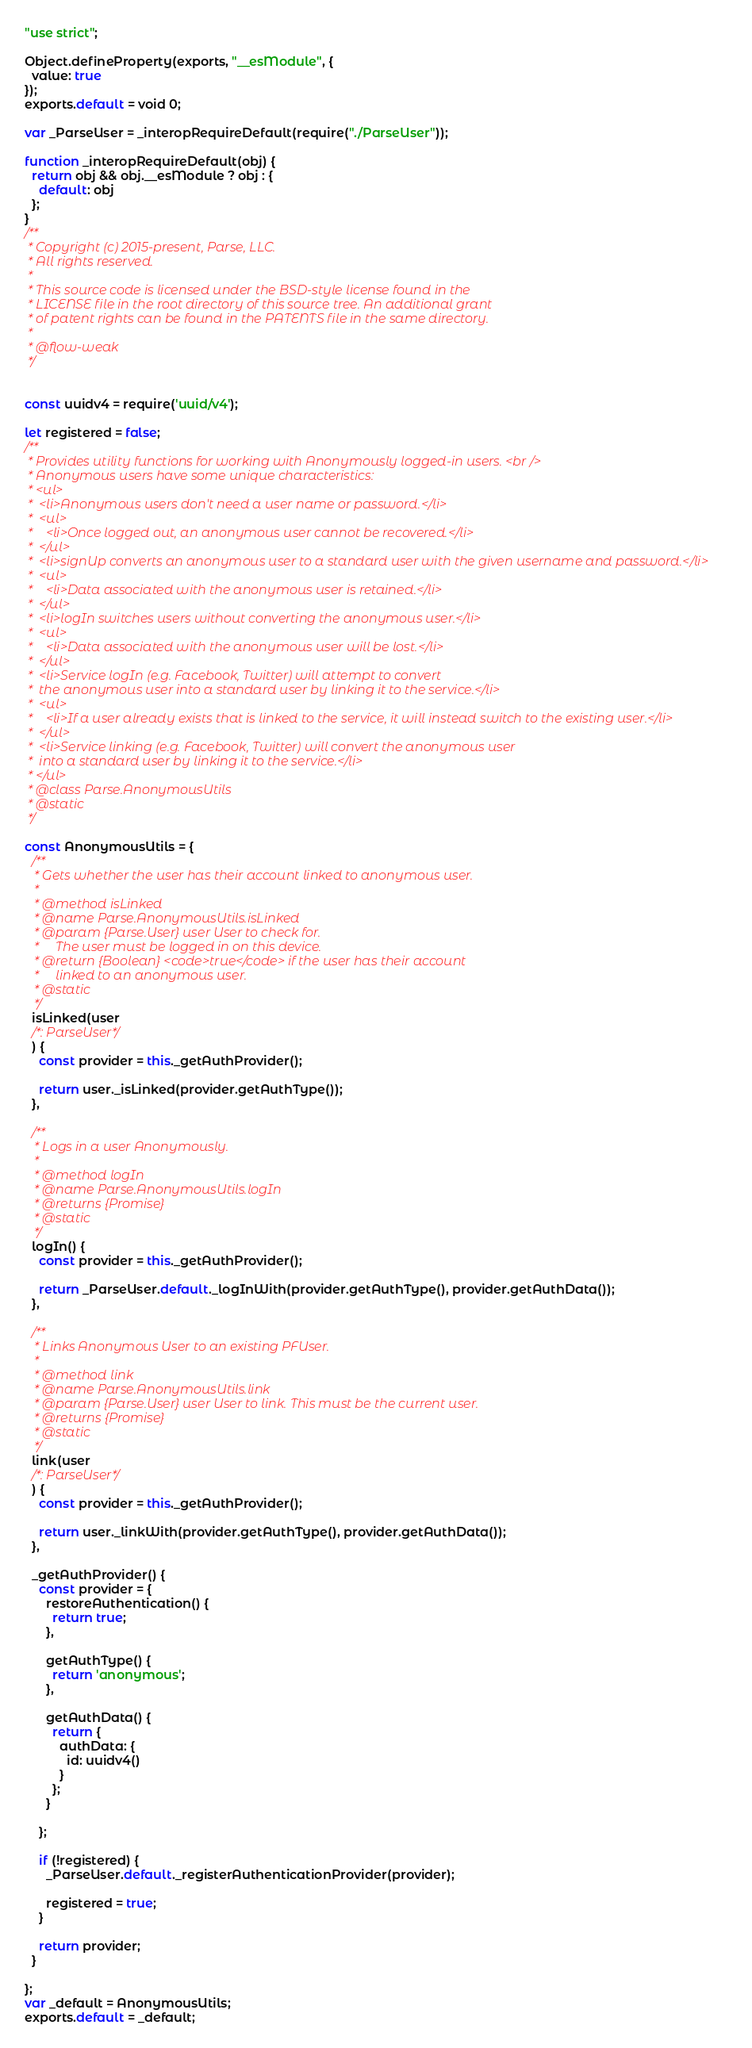Convert code to text. <code><loc_0><loc_0><loc_500><loc_500><_JavaScript_>"use strict";

Object.defineProperty(exports, "__esModule", {
  value: true
});
exports.default = void 0;

var _ParseUser = _interopRequireDefault(require("./ParseUser"));

function _interopRequireDefault(obj) {
  return obj && obj.__esModule ? obj : {
    default: obj
  };
}
/**
 * Copyright (c) 2015-present, Parse, LLC.
 * All rights reserved.
 *
 * This source code is licensed under the BSD-style license found in the
 * LICENSE file in the root directory of this source tree. An additional grant
 * of patent rights can be found in the PATENTS file in the same directory.
 *
 * @flow-weak
 */


const uuidv4 = require('uuid/v4');

let registered = false;
/**
 * Provides utility functions for working with Anonymously logged-in users. <br />
 * Anonymous users have some unique characteristics:
 * <ul>
 *  <li>Anonymous users don't need a user name or password.</li>
 *  <ul>
 *    <li>Once logged out, an anonymous user cannot be recovered.</li>
 *  </ul>
 *  <li>signUp converts an anonymous user to a standard user with the given username and password.</li>
 *  <ul>
 *    <li>Data associated with the anonymous user is retained.</li>
 *  </ul>
 *  <li>logIn switches users without converting the anonymous user.</li>
 *  <ul>
 *    <li>Data associated with the anonymous user will be lost.</li>
 *  </ul>
 *  <li>Service logIn (e.g. Facebook, Twitter) will attempt to convert
 *  the anonymous user into a standard user by linking it to the service.</li>
 *  <ul>
 *    <li>If a user already exists that is linked to the service, it will instead switch to the existing user.</li>
 *  </ul>
 *  <li>Service linking (e.g. Facebook, Twitter) will convert the anonymous user
 *  into a standard user by linking it to the service.</li>
 * </ul>
 * @class Parse.AnonymousUtils
 * @static
 */

const AnonymousUtils = {
  /**
   * Gets whether the user has their account linked to anonymous user.
   *
   * @method isLinked
   * @name Parse.AnonymousUtils.isLinked
   * @param {Parse.User} user User to check for.
   *     The user must be logged in on this device.
   * @return {Boolean} <code>true</code> if the user has their account
   *     linked to an anonymous user.
   * @static
   */
  isLinked(user
  /*: ParseUser*/
  ) {
    const provider = this._getAuthProvider();

    return user._isLinked(provider.getAuthType());
  },

  /**
   * Logs in a user Anonymously.
   *
   * @method logIn
   * @name Parse.AnonymousUtils.logIn
   * @returns {Promise}
   * @static
   */
  logIn() {
    const provider = this._getAuthProvider();

    return _ParseUser.default._logInWith(provider.getAuthType(), provider.getAuthData());
  },

  /**
   * Links Anonymous User to an existing PFUser.
   *
   * @method link
   * @name Parse.AnonymousUtils.link
   * @param {Parse.User} user User to link. This must be the current user.
   * @returns {Promise}
   * @static
   */
  link(user
  /*: ParseUser*/
  ) {
    const provider = this._getAuthProvider();

    return user._linkWith(provider.getAuthType(), provider.getAuthData());
  },

  _getAuthProvider() {
    const provider = {
      restoreAuthentication() {
        return true;
      },

      getAuthType() {
        return 'anonymous';
      },

      getAuthData() {
        return {
          authData: {
            id: uuidv4()
          }
        };
      }

    };

    if (!registered) {
      _ParseUser.default._registerAuthenticationProvider(provider);

      registered = true;
    }

    return provider;
  }

};
var _default = AnonymousUtils;
exports.default = _default;</code> 